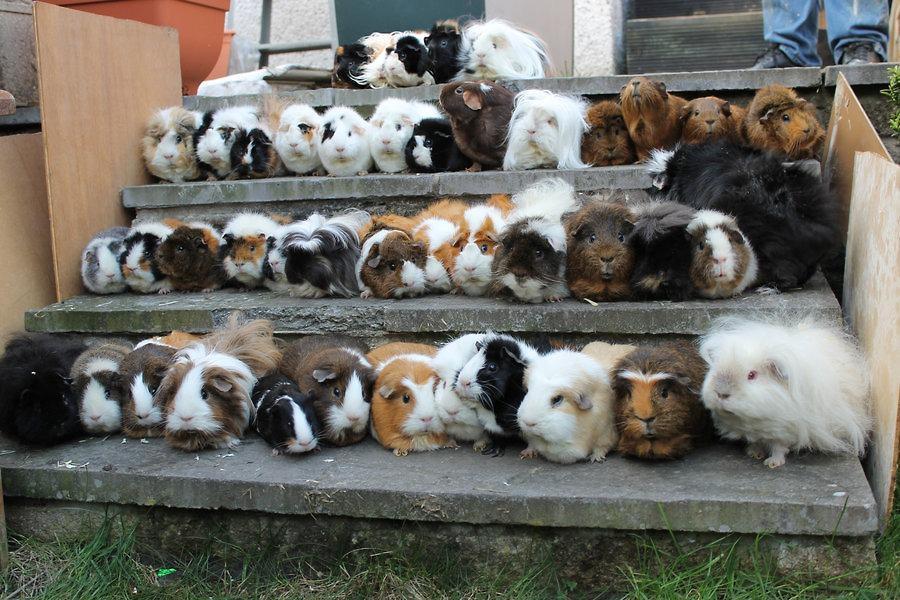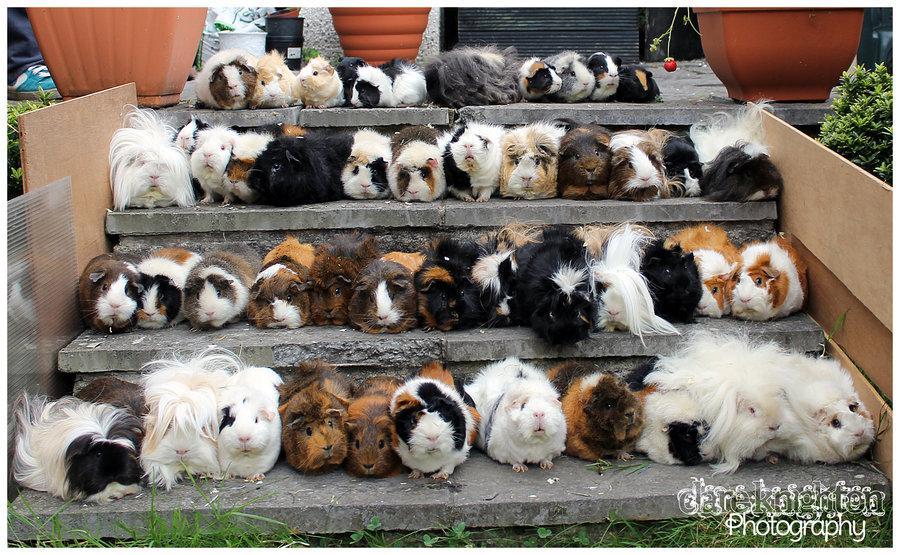The first image is the image on the left, the second image is the image on the right. Considering the images on both sides, is "Both images show a large number of guinea pigs arranged in rows on stair steps." valid? Answer yes or no. Yes. The first image is the image on the left, the second image is the image on the right. For the images shown, is this caption "Both images show variously colored hamsters arranged in stepped rows." true? Answer yes or no. Yes. 